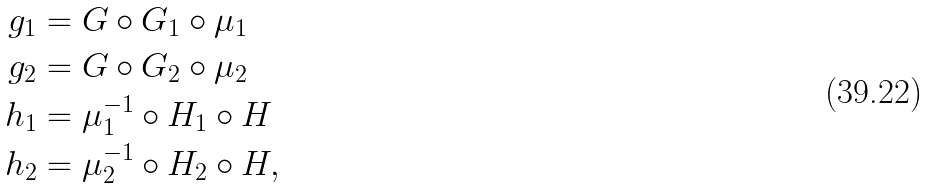Convert formula to latex. <formula><loc_0><loc_0><loc_500><loc_500>g _ { 1 } & = G \circ G _ { 1 } \circ \mu _ { 1 } \\ g _ { 2 } & = G \circ G _ { 2 } \circ \mu _ { 2 } \\ h _ { 1 } & = \mu _ { 1 } ^ { - 1 } \circ H _ { 1 } \circ H \\ h _ { 2 } & = \mu _ { 2 } ^ { - 1 } \circ H _ { 2 } \circ H ,</formula> 